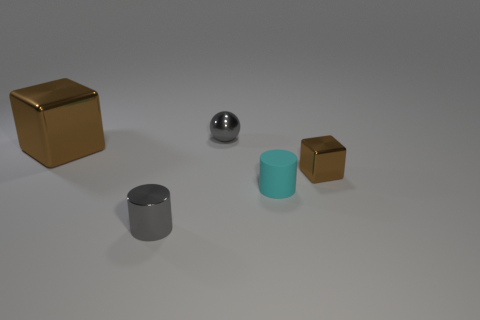Does the cylinder that is to the right of the small gray cylinder have the same color as the metallic object in front of the tiny metallic block?
Keep it short and to the point. No. Is the number of rubber things left of the big shiny thing the same as the number of small gray metallic cylinders?
Keep it short and to the point. No. There is a shiny cylinder; what number of cyan objects are in front of it?
Your answer should be very brief. 0. The gray cylinder has what size?
Give a very brief answer. Small. The cylinder that is the same material as the small brown thing is what color?
Your response must be concise. Gray. What number of gray objects are the same size as the sphere?
Keep it short and to the point. 1. Are the tiny gray object that is in front of the small brown metallic object and the small brown object made of the same material?
Offer a very short reply. Yes. Are there fewer tiny gray metallic spheres to the left of the ball than large blue shiny cubes?
Keep it short and to the point. No. What shape is the small object behind the tiny metal cube?
Provide a succinct answer. Sphere. What shape is the cyan rubber thing that is the same size as the gray cylinder?
Your response must be concise. Cylinder. 